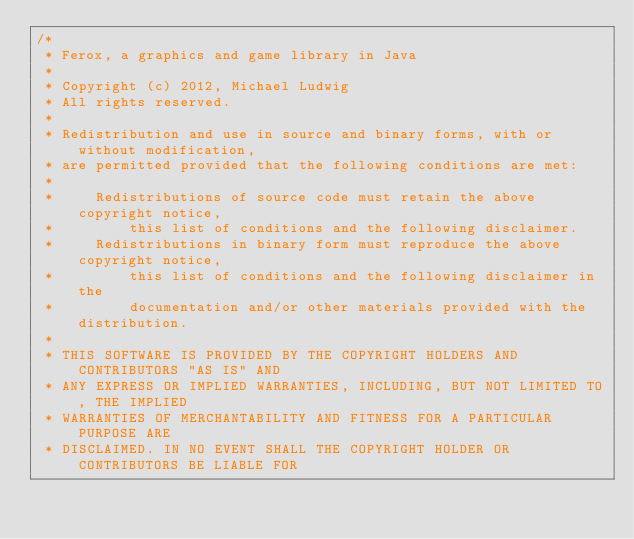<code> <loc_0><loc_0><loc_500><loc_500><_Java_>/*
 * Ferox, a graphics and game library in Java
 *
 * Copyright (c) 2012, Michael Ludwig
 * All rights reserved.
 *
 * Redistribution and use in source and binary forms, with or without modification,
 * are permitted provided that the following conditions are met:
 *
 *     Redistributions of source code must retain the above copyright notice,
 *         this list of conditions and the following disclaimer.
 *     Redistributions in binary form must reproduce the above copyright notice,
 *         this list of conditions and the following disclaimer in the
 *         documentation and/or other materials provided with the distribution.
 *
 * THIS SOFTWARE IS PROVIDED BY THE COPYRIGHT HOLDERS AND CONTRIBUTORS "AS IS" AND
 * ANY EXPRESS OR IMPLIED WARRANTIES, INCLUDING, BUT NOT LIMITED TO, THE IMPLIED
 * WARRANTIES OF MERCHANTABILITY AND FITNESS FOR A PARTICULAR PURPOSE ARE
 * DISCLAIMED. IN NO EVENT SHALL THE COPYRIGHT HOLDER OR CONTRIBUTORS BE LIABLE FOR</code> 